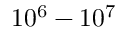<formula> <loc_0><loc_0><loc_500><loc_500>1 0 ^ { 6 } - 1 0 ^ { 7 }</formula> 